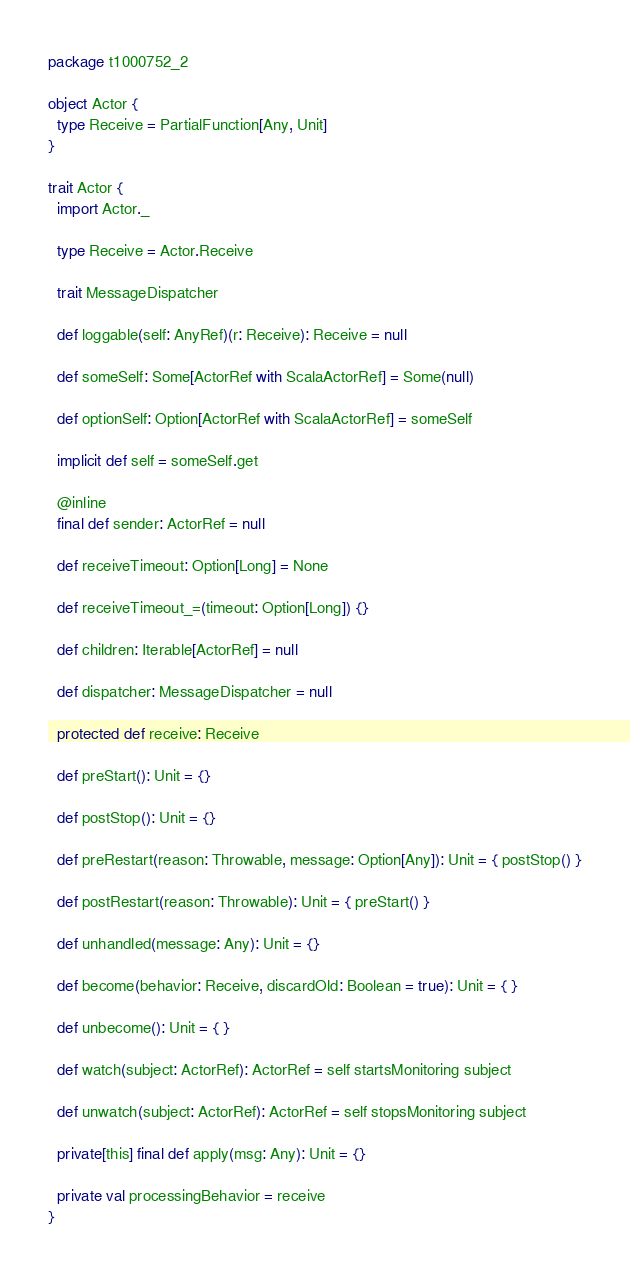Convert code to text. <code><loc_0><loc_0><loc_500><loc_500><_Scala_>package t1000752_2

object Actor {
  type Receive = PartialFunction[Any, Unit]
}

trait Actor {
  import Actor._

  type Receive = Actor.Receive

  trait MessageDispatcher

  def loggable(self: AnyRef)(r: Receive): Receive = null

  def someSelf: Some[ActorRef with ScalaActorRef] = Some(null)

  def optionSelf: Option[ActorRef with ScalaActorRef] = someSelf

  implicit def self = someSelf.get

  @inline
  final def sender: ActorRef = null

  def receiveTimeout: Option[Long] = None

  def receiveTimeout_=(timeout: Option[Long]) {}

  def children: Iterable[ActorRef] = null

  def dispatcher: MessageDispatcher = null

  protected def receive: Receive

  def preStart(): Unit = {}

  def postStop(): Unit = {}

  def preRestart(reason: Throwable, message: Option[Any]): Unit = { postStop() }

  def postRestart(reason: Throwable): Unit = { preStart() }

  def unhandled(message: Any): Unit = {}

  def become(behavior: Receive, discardOld: Boolean = true): Unit = { }

  def unbecome(): Unit = { }

  def watch(subject: ActorRef): ActorRef = self startsMonitoring subject

  def unwatch(subject: ActorRef): ActorRef = self stopsMonitoring subject

  private[this] final def apply(msg: Any): Unit = {}

  private val processingBehavior = receive
}

</code> 